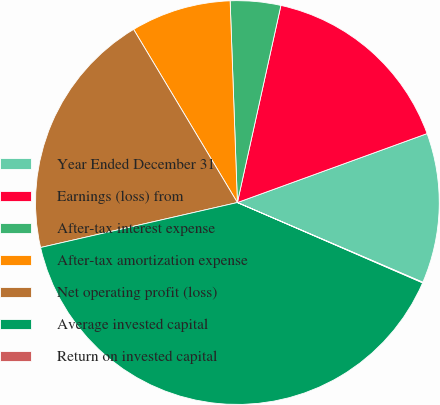<chart> <loc_0><loc_0><loc_500><loc_500><pie_chart><fcel>Year Ended December 31<fcel>Earnings (loss) from<fcel>After-tax interest expense<fcel>After-tax amortization expense<fcel>Net operating profit (loss)<fcel>Average invested capital<fcel>Return on invested capital<nl><fcel>12.01%<fcel>15.99%<fcel>4.03%<fcel>8.02%<fcel>19.98%<fcel>39.91%<fcel>0.05%<nl></chart> 